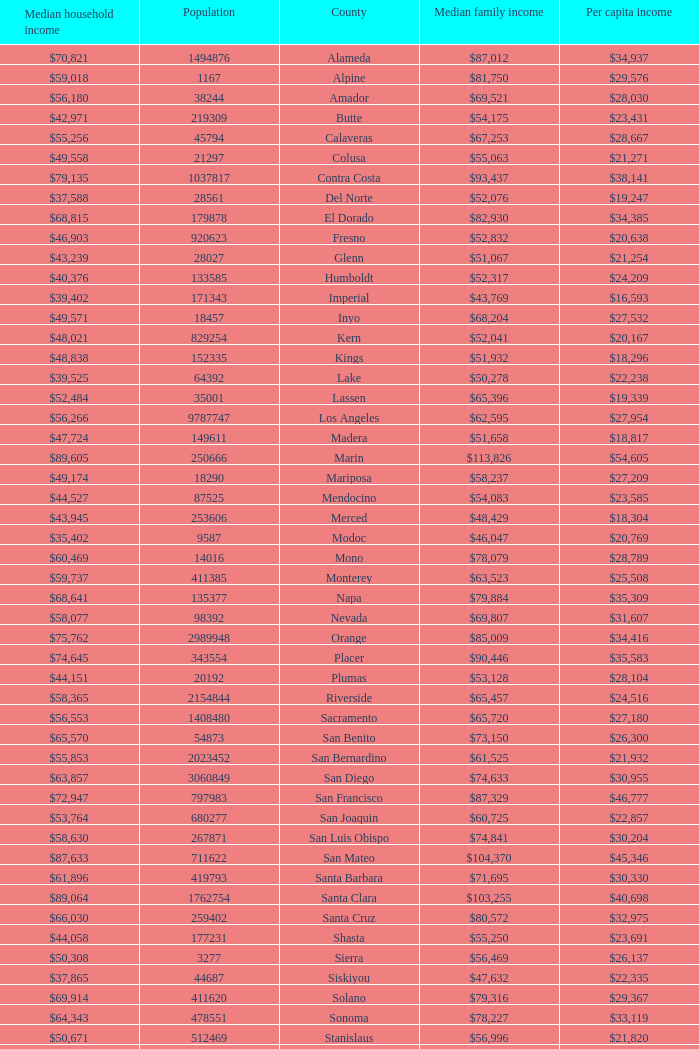Name the median family income for riverside $65,457. 